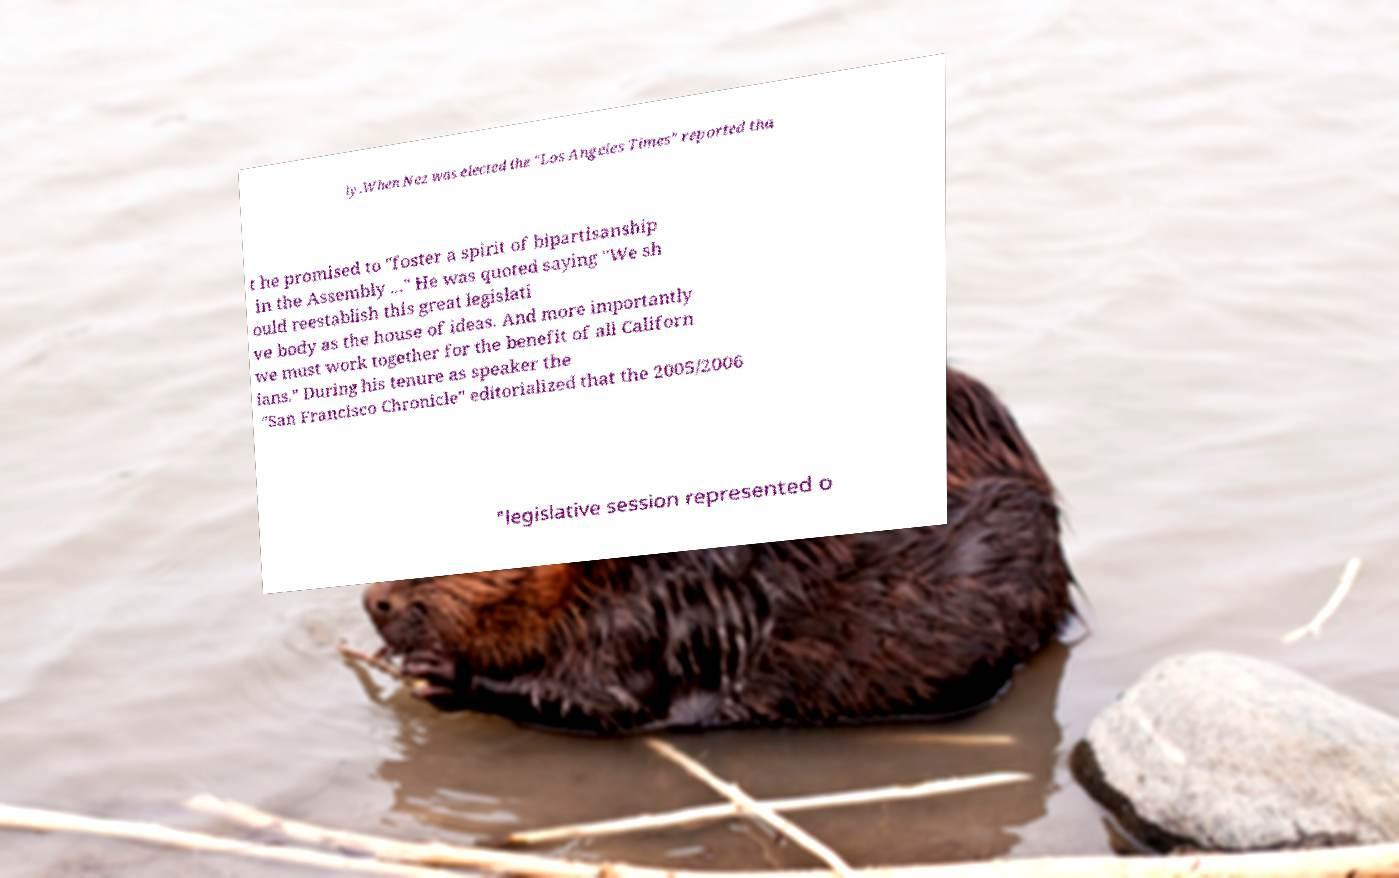Please read and relay the text visible in this image. What does it say? ly.When Nez was elected the "Los Angeles Times" reported tha t he promised to "foster a spirit of bipartisanship in the Assembly ..." He was quoted saying "We sh ould reestablish this great legislati ve body as the house of ideas. And more importantly we must work together for the benefit of all Californ ians." During his tenure as speaker the "San Francisco Chronicle" editorialized that the 2005/2006 "legislative session represented o 